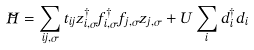Convert formula to latex. <formula><loc_0><loc_0><loc_500><loc_500>\tilde { H } = \sum _ { i j , \sigma } t _ { i j } z _ { i , \sigma } ^ { \dagger } f _ { i , \sigma } ^ { \dagger } f _ { j , \sigma } z _ { j , \sigma } + U \sum _ { i } d _ { i } ^ { \dagger } d _ { i }</formula> 